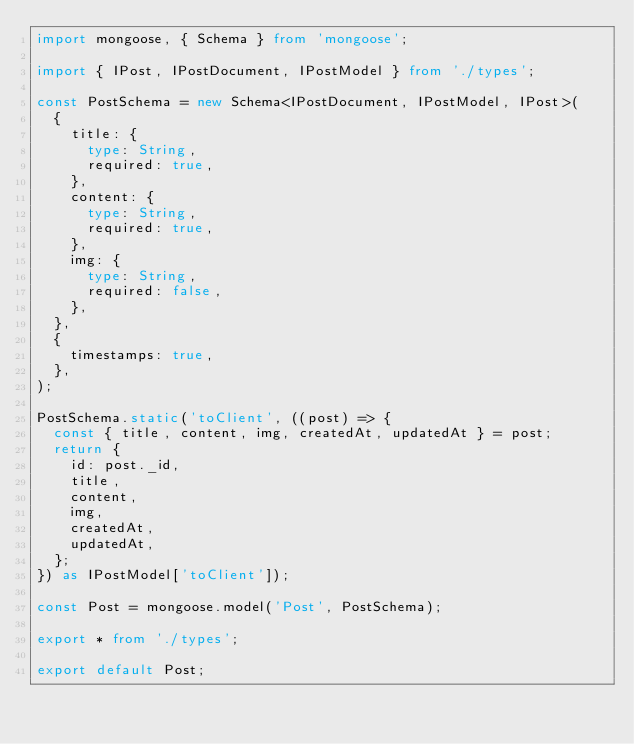<code> <loc_0><loc_0><loc_500><loc_500><_TypeScript_>import mongoose, { Schema } from 'mongoose';

import { IPost, IPostDocument, IPostModel } from './types';

const PostSchema = new Schema<IPostDocument, IPostModel, IPost>(
  {
    title: {
      type: String,
      required: true,
    },
    content: {
      type: String,
      required: true,
    },
    img: {
      type: String,
      required: false,
    },
  },
  {
    timestamps: true,
  },
);

PostSchema.static('toClient', ((post) => {
  const { title, content, img, createdAt, updatedAt } = post;
  return {
    id: post._id,
    title,
    content,
    img,
    createdAt,
    updatedAt,
  };
}) as IPostModel['toClient']);

const Post = mongoose.model('Post', PostSchema);

export * from './types';

export default Post;
</code> 